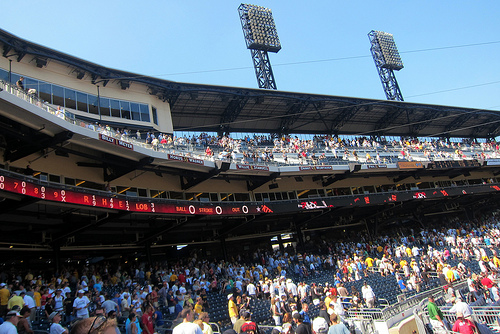<image>
Can you confirm if the man is behind the fence? Yes. From this viewpoint, the man is positioned behind the fence, with the fence partially or fully occluding the man. 